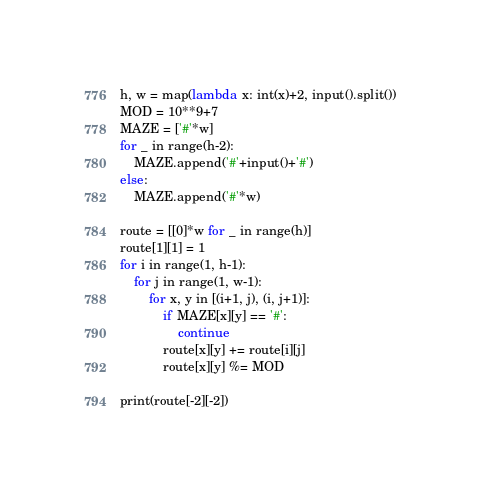<code> <loc_0><loc_0><loc_500><loc_500><_Python_>h, w = map(lambda x: int(x)+2, input().split())
MOD = 10**9+7
MAZE = ['#'*w]
for _ in range(h-2):
    MAZE.append('#'+input()+'#')
else:
    MAZE.append('#'*w)

route = [[0]*w for _ in range(h)]
route[1][1] = 1
for i in range(1, h-1):
    for j in range(1, w-1):
        for x, y in [(i+1, j), (i, j+1)]:
            if MAZE[x][y] == '#':
                continue
            route[x][y] += route[i][j]
            route[x][y] %= MOD

print(route[-2][-2])</code> 